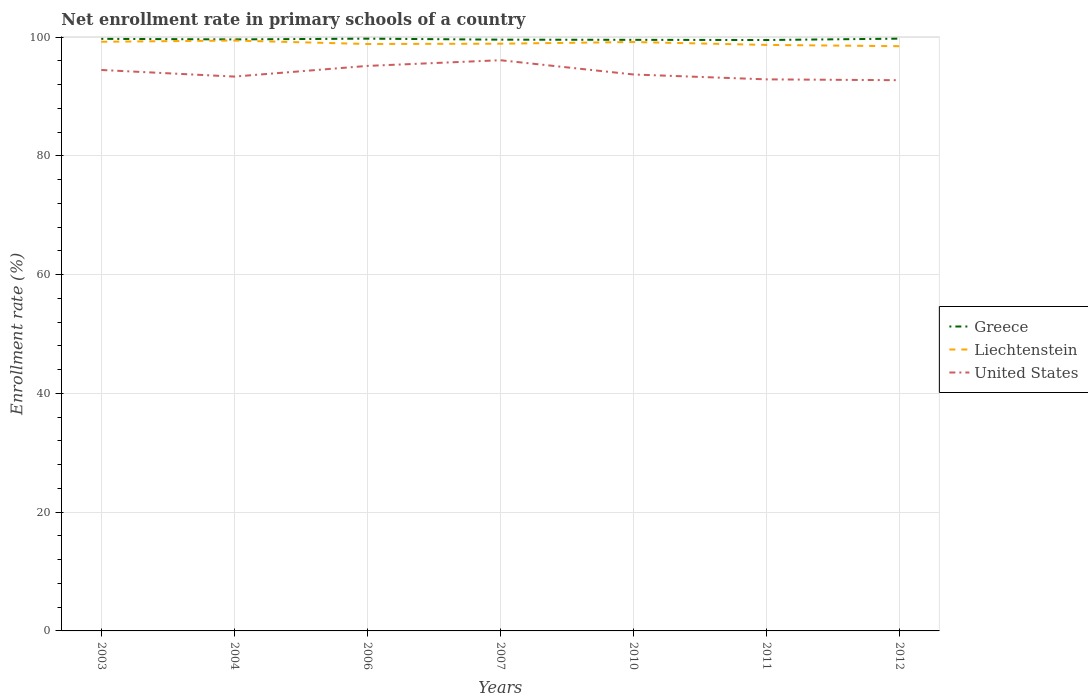Does the line corresponding to Greece intersect with the line corresponding to Liechtenstein?
Provide a succinct answer. No. Is the number of lines equal to the number of legend labels?
Provide a succinct answer. Yes. Across all years, what is the maximum enrollment rate in primary schools in United States?
Give a very brief answer. 92.75. What is the total enrollment rate in primary schools in Liechtenstein in the graph?
Provide a succinct answer. 0.53. What is the difference between the highest and the second highest enrollment rate in primary schools in Greece?
Offer a terse response. 0.23. How many lines are there?
Provide a succinct answer. 3. How many years are there in the graph?
Keep it short and to the point. 7. Are the values on the major ticks of Y-axis written in scientific E-notation?
Your answer should be compact. No. Does the graph contain any zero values?
Offer a very short reply. No. How many legend labels are there?
Provide a short and direct response. 3. What is the title of the graph?
Your answer should be compact. Net enrollment rate in primary schools of a country. What is the label or title of the X-axis?
Ensure brevity in your answer.  Years. What is the label or title of the Y-axis?
Ensure brevity in your answer.  Enrollment rate (%). What is the Enrollment rate (%) of Greece in 2003?
Ensure brevity in your answer.  99.72. What is the Enrollment rate (%) of Liechtenstein in 2003?
Your response must be concise. 99.23. What is the Enrollment rate (%) in United States in 2003?
Your response must be concise. 94.47. What is the Enrollment rate (%) of Greece in 2004?
Your response must be concise. 99.62. What is the Enrollment rate (%) in Liechtenstein in 2004?
Offer a terse response. 99.43. What is the Enrollment rate (%) in United States in 2004?
Your answer should be compact. 93.36. What is the Enrollment rate (%) of Greece in 2006?
Your answer should be compact. 99.75. What is the Enrollment rate (%) in Liechtenstein in 2006?
Make the answer very short. 98.85. What is the Enrollment rate (%) in United States in 2006?
Ensure brevity in your answer.  95.16. What is the Enrollment rate (%) in Greece in 2007?
Your answer should be compact. 99.58. What is the Enrollment rate (%) of Liechtenstein in 2007?
Your answer should be compact. 98.9. What is the Enrollment rate (%) in United States in 2007?
Keep it short and to the point. 96.12. What is the Enrollment rate (%) of Greece in 2010?
Your answer should be compact. 99.55. What is the Enrollment rate (%) of Liechtenstein in 2010?
Keep it short and to the point. 99.18. What is the Enrollment rate (%) in United States in 2010?
Make the answer very short. 93.72. What is the Enrollment rate (%) in Greece in 2011?
Keep it short and to the point. 99.52. What is the Enrollment rate (%) in Liechtenstein in 2011?
Make the answer very short. 98.7. What is the Enrollment rate (%) in United States in 2011?
Make the answer very short. 92.89. What is the Enrollment rate (%) of Greece in 2012?
Give a very brief answer. 99.75. What is the Enrollment rate (%) in Liechtenstein in 2012?
Your answer should be compact. 98.48. What is the Enrollment rate (%) of United States in 2012?
Your answer should be very brief. 92.75. Across all years, what is the maximum Enrollment rate (%) in Greece?
Provide a short and direct response. 99.75. Across all years, what is the maximum Enrollment rate (%) in Liechtenstein?
Your answer should be very brief. 99.43. Across all years, what is the maximum Enrollment rate (%) in United States?
Your answer should be very brief. 96.12. Across all years, what is the minimum Enrollment rate (%) in Greece?
Offer a terse response. 99.52. Across all years, what is the minimum Enrollment rate (%) of Liechtenstein?
Give a very brief answer. 98.48. Across all years, what is the minimum Enrollment rate (%) of United States?
Offer a terse response. 92.75. What is the total Enrollment rate (%) of Greece in the graph?
Your answer should be very brief. 697.51. What is the total Enrollment rate (%) in Liechtenstein in the graph?
Offer a very short reply. 692.78. What is the total Enrollment rate (%) in United States in the graph?
Ensure brevity in your answer.  658.49. What is the difference between the Enrollment rate (%) in Greece in 2003 and that in 2004?
Your answer should be very brief. 0.09. What is the difference between the Enrollment rate (%) in Liechtenstein in 2003 and that in 2004?
Your answer should be compact. -0.2. What is the difference between the Enrollment rate (%) of United States in 2003 and that in 2004?
Offer a very short reply. 1.11. What is the difference between the Enrollment rate (%) of Greece in 2003 and that in 2006?
Make the answer very short. -0.03. What is the difference between the Enrollment rate (%) of Liechtenstein in 2003 and that in 2006?
Give a very brief answer. 0.38. What is the difference between the Enrollment rate (%) of United States in 2003 and that in 2006?
Your answer should be compact. -0.69. What is the difference between the Enrollment rate (%) in Greece in 2003 and that in 2007?
Make the answer very short. 0.14. What is the difference between the Enrollment rate (%) of Liechtenstein in 2003 and that in 2007?
Offer a terse response. 0.33. What is the difference between the Enrollment rate (%) of United States in 2003 and that in 2007?
Give a very brief answer. -1.64. What is the difference between the Enrollment rate (%) in Greece in 2003 and that in 2010?
Keep it short and to the point. 0.16. What is the difference between the Enrollment rate (%) in Liechtenstein in 2003 and that in 2010?
Ensure brevity in your answer.  0.04. What is the difference between the Enrollment rate (%) of United States in 2003 and that in 2010?
Keep it short and to the point. 0.76. What is the difference between the Enrollment rate (%) in Greece in 2003 and that in 2011?
Provide a succinct answer. 0.19. What is the difference between the Enrollment rate (%) of Liechtenstein in 2003 and that in 2011?
Your response must be concise. 0.53. What is the difference between the Enrollment rate (%) of United States in 2003 and that in 2011?
Your answer should be very brief. 1.58. What is the difference between the Enrollment rate (%) in Greece in 2003 and that in 2012?
Give a very brief answer. -0.03. What is the difference between the Enrollment rate (%) in Liechtenstein in 2003 and that in 2012?
Your answer should be compact. 0.75. What is the difference between the Enrollment rate (%) of United States in 2003 and that in 2012?
Keep it short and to the point. 1.72. What is the difference between the Enrollment rate (%) of Greece in 2004 and that in 2006?
Offer a terse response. -0.13. What is the difference between the Enrollment rate (%) in Liechtenstein in 2004 and that in 2006?
Provide a short and direct response. 0.58. What is the difference between the Enrollment rate (%) in United States in 2004 and that in 2006?
Your answer should be very brief. -1.8. What is the difference between the Enrollment rate (%) in Greece in 2004 and that in 2007?
Your answer should be compact. 0.04. What is the difference between the Enrollment rate (%) in Liechtenstein in 2004 and that in 2007?
Provide a short and direct response. 0.53. What is the difference between the Enrollment rate (%) in United States in 2004 and that in 2007?
Provide a succinct answer. -2.75. What is the difference between the Enrollment rate (%) of Greece in 2004 and that in 2010?
Your answer should be compact. 0.07. What is the difference between the Enrollment rate (%) in Liechtenstein in 2004 and that in 2010?
Ensure brevity in your answer.  0.25. What is the difference between the Enrollment rate (%) in United States in 2004 and that in 2010?
Ensure brevity in your answer.  -0.35. What is the difference between the Enrollment rate (%) of Greece in 2004 and that in 2011?
Offer a very short reply. 0.1. What is the difference between the Enrollment rate (%) of Liechtenstein in 2004 and that in 2011?
Keep it short and to the point. 0.73. What is the difference between the Enrollment rate (%) in United States in 2004 and that in 2011?
Your response must be concise. 0.47. What is the difference between the Enrollment rate (%) in Greece in 2004 and that in 2012?
Your answer should be very brief. -0.13. What is the difference between the Enrollment rate (%) in Liechtenstein in 2004 and that in 2012?
Keep it short and to the point. 0.95. What is the difference between the Enrollment rate (%) in United States in 2004 and that in 2012?
Give a very brief answer. 0.61. What is the difference between the Enrollment rate (%) of Greece in 2006 and that in 2007?
Provide a short and direct response. 0.17. What is the difference between the Enrollment rate (%) of Liechtenstein in 2006 and that in 2007?
Your response must be concise. -0.05. What is the difference between the Enrollment rate (%) of United States in 2006 and that in 2007?
Provide a short and direct response. -0.96. What is the difference between the Enrollment rate (%) in Greece in 2006 and that in 2010?
Make the answer very short. 0.2. What is the difference between the Enrollment rate (%) in United States in 2006 and that in 2010?
Ensure brevity in your answer.  1.44. What is the difference between the Enrollment rate (%) of Greece in 2006 and that in 2011?
Keep it short and to the point. 0.23. What is the difference between the Enrollment rate (%) of Liechtenstein in 2006 and that in 2011?
Keep it short and to the point. 0.15. What is the difference between the Enrollment rate (%) of United States in 2006 and that in 2011?
Ensure brevity in your answer.  2.27. What is the difference between the Enrollment rate (%) of Greece in 2006 and that in 2012?
Keep it short and to the point. 0. What is the difference between the Enrollment rate (%) of Liechtenstein in 2006 and that in 2012?
Offer a terse response. 0.37. What is the difference between the Enrollment rate (%) in United States in 2006 and that in 2012?
Provide a succinct answer. 2.41. What is the difference between the Enrollment rate (%) of Greece in 2007 and that in 2010?
Keep it short and to the point. 0.03. What is the difference between the Enrollment rate (%) in Liechtenstein in 2007 and that in 2010?
Your response must be concise. -0.28. What is the difference between the Enrollment rate (%) of United States in 2007 and that in 2010?
Your answer should be very brief. 2.4. What is the difference between the Enrollment rate (%) in Greece in 2007 and that in 2011?
Offer a terse response. 0.06. What is the difference between the Enrollment rate (%) in Liechtenstein in 2007 and that in 2011?
Your answer should be compact. 0.2. What is the difference between the Enrollment rate (%) of United States in 2007 and that in 2011?
Make the answer very short. 3.22. What is the difference between the Enrollment rate (%) in Greece in 2007 and that in 2012?
Provide a short and direct response. -0.17. What is the difference between the Enrollment rate (%) in Liechtenstein in 2007 and that in 2012?
Your answer should be very brief. 0.42. What is the difference between the Enrollment rate (%) of United States in 2007 and that in 2012?
Make the answer very short. 3.37. What is the difference between the Enrollment rate (%) of Greece in 2010 and that in 2011?
Make the answer very short. 0.03. What is the difference between the Enrollment rate (%) of Liechtenstein in 2010 and that in 2011?
Your answer should be compact. 0.49. What is the difference between the Enrollment rate (%) in United States in 2010 and that in 2011?
Ensure brevity in your answer.  0.82. What is the difference between the Enrollment rate (%) in Greece in 2010 and that in 2012?
Offer a terse response. -0.2. What is the difference between the Enrollment rate (%) in Liechtenstein in 2010 and that in 2012?
Provide a succinct answer. 0.71. What is the difference between the Enrollment rate (%) in United States in 2010 and that in 2012?
Your response must be concise. 0.96. What is the difference between the Enrollment rate (%) in Greece in 2011 and that in 2012?
Provide a short and direct response. -0.23. What is the difference between the Enrollment rate (%) in Liechtenstein in 2011 and that in 2012?
Provide a short and direct response. 0.22. What is the difference between the Enrollment rate (%) in United States in 2011 and that in 2012?
Offer a terse response. 0.14. What is the difference between the Enrollment rate (%) of Greece in 2003 and the Enrollment rate (%) of Liechtenstein in 2004?
Give a very brief answer. 0.29. What is the difference between the Enrollment rate (%) in Greece in 2003 and the Enrollment rate (%) in United States in 2004?
Your answer should be compact. 6.35. What is the difference between the Enrollment rate (%) in Liechtenstein in 2003 and the Enrollment rate (%) in United States in 2004?
Your answer should be very brief. 5.86. What is the difference between the Enrollment rate (%) of Greece in 2003 and the Enrollment rate (%) of Liechtenstein in 2006?
Ensure brevity in your answer.  0.87. What is the difference between the Enrollment rate (%) of Greece in 2003 and the Enrollment rate (%) of United States in 2006?
Offer a very short reply. 4.56. What is the difference between the Enrollment rate (%) in Liechtenstein in 2003 and the Enrollment rate (%) in United States in 2006?
Your response must be concise. 4.07. What is the difference between the Enrollment rate (%) of Greece in 2003 and the Enrollment rate (%) of Liechtenstein in 2007?
Keep it short and to the point. 0.82. What is the difference between the Enrollment rate (%) of Greece in 2003 and the Enrollment rate (%) of United States in 2007?
Make the answer very short. 3.6. What is the difference between the Enrollment rate (%) in Liechtenstein in 2003 and the Enrollment rate (%) in United States in 2007?
Keep it short and to the point. 3.11. What is the difference between the Enrollment rate (%) of Greece in 2003 and the Enrollment rate (%) of Liechtenstein in 2010?
Give a very brief answer. 0.53. What is the difference between the Enrollment rate (%) in Greece in 2003 and the Enrollment rate (%) in United States in 2010?
Your answer should be compact. 6. What is the difference between the Enrollment rate (%) in Liechtenstein in 2003 and the Enrollment rate (%) in United States in 2010?
Keep it short and to the point. 5.51. What is the difference between the Enrollment rate (%) of Greece in 2003 and the Enrollment rate (%) of Liechtenstein in 2011?
Give a very brief answer. 1.02. What is the difference between the Enrollment rate (%) in Greece in 2003 and the Enrollment rate (%) in United States in 2011?
Give a very brief answer. 6.82. What is the difference between the Enrollment rate (%) in Liechtenstein in 2003 and the Enrollment rate (%) in United States in 2011?
Give a very brief answer. 6.33. What is the difference between the Enrollment rate (%) in Greece in 2003 and the Enrollment rate (%) in Liechtenstein in 2012?
Provide a short and direct response. 1.24. What is the difference between the Enrollment rate (%) in Greece in 2003 and the Enrollment rate (%) in United States in 2012?
Your answer should be very brief. 6.96. What is the difference between the Enrollment rate (%) in Liechtenstein in 2003 and the Enrollment rate (%) in United States in 2012?
Provide a short and direct response. 6.47. What is the difference between the Enrollment rate (%) of Greece in 2004 and the Enrollment rate (%) of Liechtenstein in 2006?
Provide a succinct answer. 0.77. What is the difference between the Enrollment rate (%) of Greece in 2004 and the Enrollment rate (%) of United States in 2006?
Your answer should be very brief. 4.46. What is the difference between the Enrollment rate (%) of Liechtenstein in 2004 and the Enrollment rate (%) of United States in 2006?
Provide a succinct answer. 4.27. What is the difference between the Enrollment rate (%) in Greece in 2004 and the Enrollment rate (%) in Liechtenstein in 2007?
Give a very brief answer. 0.72. What is the difference between the Enrollment rate (%) of Greece in 2004 and the Enrollment rate (%) of United States in 2007?
Ensure brevity in your answer.  3.51. What is the difference between the Enrollment rate (%) of Liechtenstein in 2004 and the Enrollment rate (%) of United States in 2007?
Your answer should be compact. 3.31. What is the difference between the Enrollment rate (%) in Greece in 2004 and the Enrollment rate (%) in Liechtenstein in 2010?
Offer a very short reply. 0.44. What is the difference between the Enrollment rate (%) in Greece in 2004 and the Enrollment rate (%) in United States in 2010?
Offer a terse response. 5.91. What is the difference between the Enrollment rate (%) of Liechtenstein in 2004 and the Enrollment rate (%) of United States in 2010?
Keep it short and to the point. 5.71. What is the difference between the Enrollment rate (%) of Greece in 2004 and the Enrollment rate (%) of Liechtenstein in 2011?
Offer a very short reply. 0.93. What is the difference between the Enrollment rate (%) in Greece in 2004 and the Enrollment rate (%) in United States in 2011?
Provide a succinct answer. 6.73. What is the difference between the Enrollment rate (%) in Liechtenstein in 2004 and the Enrollment rate (%) in United States in 2011?
Ensure brevity in your answer.  6.54. What is the difference between the Enrollment rate (%) of Greece in 2004 and the Enrollment rate (%) of Liechtenstein in 2012?
Give a very brief answer. 1.14. What is the difference between the Enrollment rate (%) of Greece in 2004 and the Enrollment rate (%) of United States in 2012?
Ensure brevity in your answer.  6.87. What is the difference between the Enrollment rate (%) of Liechtenstein in 2004 and the Enrollment rate (%) of United States in 2012?
Offer a terse response. 6.68. What is the difference between the Enrollment rate (%) of Greece in 2006 and the Enrollment rate (%) of Liechtenstein in 2007?
Ensure brevity in your answer.  0.85. What is the difference between the Enrollment rate (%) of Greece in 2006 and the Enrollment rate (%) of United States in 2007?
Your response must be concise. 3.63. What is the difference between the Enrollment rate (%) in Liechtenstein in 2006 and the Enrollment rate (%) in United States in 2007?
Your response must be concise. 2.73. What is the difference between the Enrollment rate (%) in Greece in 2006 and the Enrollment rate (%) in Liechtenstein in 2010?
Offer a terse response. 0.57. What is the difference between the Enrollment rate (%) in Greece in 2006 and the Enrollment rate (%) in United States in 2010?
Ensure brevity in your answer.  6.03. What is the difference between the Enrollment rate (%) in Liechtenstein in 2006 and the Enrollment rate (%) in United States in 2010?
Your response must be concise. 5.13. What is the difference between the Enrollment rate (%) of Greece in 2006 and the Enrollment rate (%) of Liechtenstein in 2011?
Keep it short and to the point. 1.05. What is the difference between the Enrollment rate (%) in Greece in 2006 and the Enrollment rate (%) in United States in 2011?
Make the answer very short. 6.86. What is the difference between the Enrollment rate (%) in Liechtenstein in 2006 and the Enrollment rate (%) in United States in 2011?
Offer a very short reply. 5.96. What is the difference between the Enrollment rate (%) of Greece in 2006 and the Enrollment rate (%) of Liechtenstein in 2012?
Give a very brief answer. 1.27. What is the difference between the Enrollment rate (%) of Greece in 2006 and the Enrollment rate (%) of United States in 2012?
Make the answer very short. 7. What is the difference between the Enrollment rate (%) of Liechtenstein in 2006 and the Enrollment rate (%) of United States in 2012?
Provide a succinct answer. 6.1. What is the difference between the Enrollment rate (%) of Greece in 2007 and the Enrollment rate (%) of Liechtenstein in 2010?
Your answer should be very brief. 0.4. What is the difference between the Enrollment rate (%) in Greece in 2007 and the Enrollment rate (%) in United States in 2010?
Your answer should be very brief. 5.87. What is the difference between the Enrollment rate (%) of Liechtenstein in 2007 and the Enrollment rate (%) of United States in 2010?
Give a very brief answer. 5.18. What is the difference between the Enrollment rate (%) of Greece in 2007 and the Enrollment rate (%) of Liechtenstein in 2011?
Provide a succinct answer. 0.89. What is the difference between the Enrollment rate (%) in Greece in 2007 and the Enrollment rate (%) in United States in 2011?
Ensure brevity in your answer.  6.69. What is the difference between the Enrollment rate (%) of Liechtenstein in 2007 and the Enrollment rate (%) of United States in 2011?
Provide a succinct answer. 6.01. What is the difference between the Enrollment rate (%) in Greece in 2007 and the Enrollment rate (%) in Liechtenstein in 2012?
Provide a short and direct response. 1.1. What is the difference between the Enrollment rate (%) of Greece in 2007 and the Enrollment rate (%) of United States in 2012?
Your answer should be compact. 6.83. What is the difference between the Enrollment rate (%) of Liechtenstein in 2007 and the Enrollment rate (%) of United States in 2012?
Your answer should be very brief. 6.15. What is the difference between the Enrollment rate (%) in Greece in 2010 and the Enrollment rate (%) in Liechtenstein in 2011?
Make the answer very short. 0.86. What is the difference between the Enrollment rate (%) in Greece in 2010 and the Enrollment rate (%) in United States in 2011?
Ensure brevity in your answer.  6.66. What is the difference between the Enrollment rate (%) of Liechtenstein in 2010 and the Enrollment rate (%) of United States in 2011?
Give a very brief answer. 6.29. What is the difference between the Enrollment rate (%) in Greece in 2010 and the Enrollment rate (%) in Liechtenstein in 2012?
Provide a short and direct response. 1.07. What is the difference between the Enrollment rate (%) of Liechtenstein in 2010 and the Enrollment rate (%) of United States in 2012?
Keep it short and to the point. 6.43. What is the difference between the Enrollment rate (%) of Greece in 2011 and the Enrollment rate (%) of Liechtenstein in 2012?
Give a very brief answer. 1.04. What is the difference between the Enrollment rate (%) in Greece in 2011 and the Enrollment rate (%) in United States in 2012?
Offer a very short reply. 6.77. What is the difference between the Enrollment rate (%) in Liechtenstein in 2011 and the Enrollment rate (%) in United States in 2012?
Give a very brief answer. 5.94. What is the average Enrollment rate (%) in Greece per year?
Ensure brevity in your answer.  99.64. What is the average Enrollment rate (%) of Liechtenstein per year?
Provide a short and direct response. 98.97. What is the average Enrollment rate (%) in United States per year?
Keep it short and to the point. 94.07. In the year 2003, what is the difference between the Enrollment rate (%) in Greece and Enrollment rate (%) in Liechtenstein?
Provide a short and direct response. 0.49. In the year 2003, what is the difference between the Enrollment rate (%) in Greece and Enrollment rate (%) in United States?
Provide a succinct answer. 5.24. In the year 2003, what is the difference between the Enrollment rate (%) in Liechtenstein and Enrollment rate (%) in United States?
Provide a succinct answer. 4.75. In the year 2004, what is the difference between the Enrollment rate (%) of Greece and Enrollment rate (%) of Liechtenstein?
Your answer should be very brief. 0.19. In the year 2004, what is the difference between the Enrollment rate (%) in Greece and Enrollment rate (%) in United States?
Your answer should be very brief. 6.26. In the year 2004, what is the difference between the Enrollment rate (%) of Liechtenstein and Enrollment rate (%) of United States?
Provide a succinct answer. 6.07. In the year 2006, what is the difference between the Enrollment rate (%) in Greece and Enrollment rate (%) in Liechtenstein?
Provide a succinct answer. 0.9. In the year 2006, what is the difference between the Enrollment rate (%) of Greece and Enrollment rate (%) of United States?
Give a very brief answer. 4.59. In the year 2006, what is the difference between the Enrollment rate (%) of Liechtenstein and Enrollment rate (%) of United States?
Your answer should be very brief. 3.69. In the year 2007, what is the difference between the Enrollment rate (%) in Greece and Enrollment rate (%) in Liechtenstein?
Offer a terse response. 0.68. In the year 2007, what is the difference between the Enrollment rate (%) of Greece and Enrollment rate (%) of United States?
Offer a very short reply. 3.46. In the year 2007, what is the difference between the Enrollment rate (%) in Liechtenstein and Enrollment rate (%) in United States?
Give a very brief answer. 2.78. In the year 2010, what is the difference between the Enrollment rate (%) in Greece and Enrollment rate (%) in Liechtenstein?
Provide a succinct answer. 0.37. In the year 2010, what is the difference between the Enrollment rate (%) in Greece and Enrollment rate (%) in United States?
Your response must be concise. 5.84. In the year 2010, what is the difference between the Enrollment rate (%) in Liechtenstein and Enrollment rate (%) in United States?
Offer a terse response. 5.47. In the year 2011, what is the difference between the Enrollment rate (%) of Greece and Enrollment rate (%) of Liechtenstein?
Your answer should be compact. 0.83. In the year 2011, what is the difference between the Enrollment rate (%) in Greece and Enrollment rate (%) in United States?
Provide a short and direct response. 6.63. In the year 2011, what is the difference between the Enrollment rate (%) in Liechtenstein and Enrollment rate (%) in United States?
Provide a short and direct response. 5.8. In the year 2012, what is the difference between the Enrollment rate (%) of Greece and Enrollment rate (%) of Liechtenstein?
Keep it short and to the point. 1.27. In the year 2012, what is the difference between the Enrollment rate (%) of Greece and Enrollment rate (%) of United States?
Offer a very short reply. 7. In the year 2012, what is the difference between the Enrollment rate (%) of Liechtenstein and Enrollment rate (%) of United States?
Your answer should be compact. 5.73. What is the ratio of the Enrollment rate (%) in Greece in 2003 to that in 2004?
Make the answer very short. 1. What is the ratio of the Enrollment rate (%) of United States in 2003 to that in 2004?
Make the answer very short. 1.01. What is the ratio of the Enrollment rate (%) in Greece in 2003 to that in 2006?
Offer a very short reply. 1. What is the ratio of the Enrollment rate (%) in United States in 2003 to that in 2006?
Keep it short and to the point. 0.99. What is the ratio of the Enrollment rate (%) of Greece in 2003 to that in 2007?
Offer a terse response. 1. What is the ratio of the Enrollment rate (%) in United States in 2003 to that in 2007?
Provide a short and direct response. 0.98. What is the ratio of the Enrollment rate (%) in Greece in 2003 to that in 2010?
Provide a short and direct response. 1. What is the ratio of the Enrollment rate (%) in Liechtenstein in 2003 to that in 2011?
Provide a short and direct response. 1.01. What is the ratio of the Enrollment rate (%) in United States in 2003 to that in 2011?
Offer a terse response. 1.02. What is the ratio of the Enrollment rate (%) in Greece in 2003 to that in 2012?
Provide a succinct answer. 1. What is the ratio of the Enrollment rate (%) in Liechtenstein in 2003 to that in 2012?
Keep it short and to the point. 1.01. What is the ratio of the Enrollment rate (%) of United States in 2003 to that in 2012?
Your response must be concise. 1.02. What is the ratio of the Enrollment rate (%) in Greece in 2004 to that in 2006?
Offer a terse response. 1. What is the ratio of the Enrollment rate (%) in Liechtenstein in 2004 to that in 2006?
Your answer should be very brief. 1.01. What is the ratio of the Enrollment rate (%) in United States in 2004 to that in 2006?
Provide a succinct answer. 0.98. What is the ratio of the Enrollment rate (%) of Greece in 2004 to that in 2007?
Provide a short and direct response. 1. What is the ratio of the Enrollment rate (%) in Liechtenstein in 2004 to that in 2007?
Offer a terse response. 1.01. What is the ratio of the Enrollment rate (%) in United States in 2004 to that in 2007?
Your response must be concise. 0.97. What is the ratio of the Enrollment rate (%) of Liechtenstein in 2004 to that in 2011?
Your answer should be compact. 1.01. What is the ratio of the Enrollment rate (%) in Greece in 2004 to that in 2012?
Provide a succinct answer. 1. What is the ratio of the Enrollment rate (%) in Liechtenstein in 2004 to that in 2012?
Give a very brief answer. 1.01. What is the ratio of the Enrollment rate (%) of United States in 2004 to that in 2012?
Your answer should be very brief. 1.01. What is the ratio of the Enrollment rate (%) in Greece in 2006 to that in 2007?
Keep it short and to the point. 1. What is the ratio of the Enrollment rate (%) in Greece in 2006 to that in 2010?
Keep it short and to the point. 1. What is the ratio of the Enrollment rate (%) in United States in 2006 to that in 2010?
Keep it short and to the point. 1.02. What is the ratio of the Enrollment rate (%) in United States in 2006 to that in 2011?
Your answer should be compact. 1.02. What is the ratio of the Enrollment rate (%) in Greece in 2006 to that in 2012?
Make the answer very short. 1. What is the ratio of the Enrollment rate (%) in Liechtenstein in 2006 to that in 2012?
Give a very brief answer. 1. What is the ratio of the Enrollment rate (%) of United States in 2006 to that in 2012?
Your answer should be compact. 1.03. What is the ratio of the Enrollment rate (%) of United States in 2007 to that in 2010?
Make the answer very short. 1.03. What is the ratio of the Enrollment rate (%) of Greece in 2007 to that in 2011?
Provide a short and direct response. 1. What is the ratio of the Enrollment rate (%) of Liechtenstein in 2007 to that in 2011?
Provide a succinct answer. 1. What is the ratio of the Enrollment rate (%) in United States in 2007 to that in 2011?
Provide a succinct answer. 1.03. What is the ratio of the Enrollment rate (%) in Greece in 2007 to that in 2012?
Your response must be concise. 1. What is the ratio of the Enrollment rate (%) in Liechtenstein in 2007 to that in 2012?
Your response must be concise. 1. What is the ratio of the Enrollment rate (%) in United States in 2007 to that in 2012?
Your answer should be very brief. 1.04. What is the ratio of the Enrollment rate (%) of Liechtenstein in 2010 to that in 2011?
Provide a succinct answer. 1. What is the ratio of the Enrollment rate (%) in United States in 2010 to that in 2011?
Offer a very short reply. 1.01. What is the ratio of the Enrollment rate (%) of Liechtenstein in 2010 to that in 2012?
Your answer should be very brief. 1.01. What is the ratio of the Enrollment rate (%) in United States in 2010 to that in 2012?
Provide a succinct answer. 1.01. What is the ratio of the Enrollment rate (%) of United States in 2011 to that in 2012?
Ensure brevity in your answer.  1. What is the difference between the highest and the second highest Enrollment rate (%) of Liechtenstein?
Provide a short and direct response. 0.2. What is the difference between the highest and the second highest Enrollment rate (%) in United States?
Give a very brief answer. 0.96. What is the difference between the highest and the lowest Enrollment rate (%) of Greece?
Provide a succinct answer. 0.23. What is the difference between the highest and the lowest Enrollment rate (%) of Liechtenstein?
Make the answer very short. 0.95. What is the difference between the highest and the lowest Enrollment rate (%) in United States?
Your response must be concise. 3.37. 